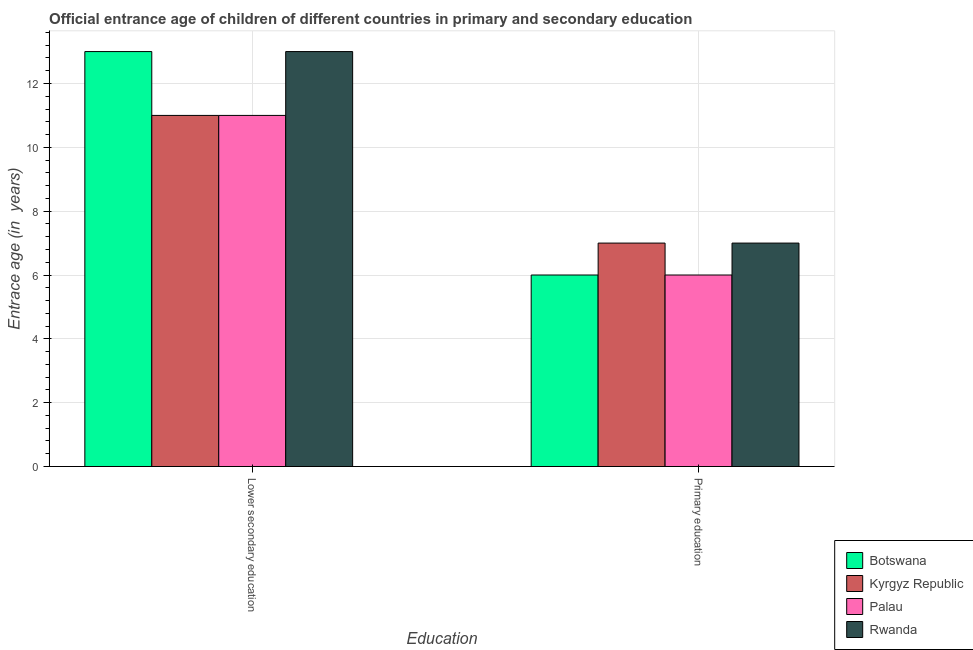Are the number of bars per tick equal to the number of legend labels?
Give a very brief answer. Yes. Are the number of bars on each tick of the X-axis equal?
Your answer should be compact. Yes. How many bars are there on the 1st tick from the left?
Provide a succinct answer. 4. How many bars are there on the 1st tick from the right?
Offer a terse response. 4. What is the label of the 2nd group of bars from the left?
Offer a very short reply. Primary education. What is the entrance age of chiildren in primary education in Botswana?
Offer a terse response. 6. Across all countries, what is the maximum entrance age of chiildren in primary education?
Make the answer very short. 7. Across all countries, what is the minimum entrance age of children in lower secondary education?
Provide a short and direct response. 11. In which country was the entrance age of chiildren in primary education maximum?
Provide a short and direct response. Kyrgyz Republic. In which country was the entrance age of children in lower secondary education minimum?
Your response must be concise. Kyrgyz Republic. What is the total entrance age of chiildren in primary education in the graph?
Your answer should be compact. 26. What is the difference between the entrance age of chiildren in primary education in Botswana and that in Kyrgyz Republic?
Give a very brief answer. -1. What is the difference between the entrance age of children in lower secondary education in Rwanda and the entrance age of chiildren in primary education in Palau?
Ensure brevity in your answer.  7. What is the difference between the entrance age of children in lower secondary education and entrance age of chiildren in primary education in Kyrgyz Republic?
Provide a succinct answer. 4. What is the ratio of the entrance age of chiildren in primary education in Botswana to that in Kyrgyz Republic?
Ensure brevity in your answer.  0.86. What does the 4th bar from the left in Primary education represents?
Offer a terse response. Rwanda. What does the 2nd bar from the right in Lower secondary education represents?
Offer a terse response. Palau. Are all the bars in the graph horizontal?
Keep it short and to the point. No. What is the difference between two consecutive major ticks on the Y-axis?
Your answer should be compact. 2. Where does the legend appear in the graph?
Your response must be concise. Bottom right. What is the title of the graph?
Offer a very short reply. Official entrance age of children of different countries in primary and secondary education. Does "Bangladesh" appear as one of the legend labels in the graph?
Keep it short and to the point. No. What is the label or title of the X-axis?
Give a very brief answer. Education. What is the label or title of the Y-axis?
Provide a succinct answer. Entrace age (in  years). What is the Entrace age (in  years) in Palau in Lower secondary education?
Your answer should be compact. 11. What is the Entrace age (in  years) in Botswana in Primary education?
Your answer should be compact. 6. What is the Entrace age (in  years) of Rwanda in Primary education?
Your answer should be compact. 7. Across all Education, what is the maximum Entrace age (in  years) in Kyrgyz Republic?
Provide a succinct answer. 11. Across all Education, what is the maximum Entrace age (in  years) of Palau?
Your answer should be compact. 11. Across all Education, what is the maximum Entrace age (in  years) of Rwanda?
Ensure brevity in your answer.  13. Across all Education, what is the minimum Entrace age (in  years) of Kyrgyz Republic?
Offer a terse response. 7. Across all Education, what is the minimum Entrace age (in  years) of Palau?
Your answer should be compact. 6. Across all Education, what is the minimum Entrace age (in  years) in Rwanda?
Keep it short and to the point. 7. What is the total Entrace age (in  years) in Kyrgyz Republic in the graph?
Ensure brevity in your answer.  18. What is the total Entrace age (in  years) in Palau in the graph?
Offer a very short reply. 17. What is the total Entrace age (in  years) of Rwanda in the graph?
Offer a very short reply. 20. What is the difference between the Entrace age (in  years) of Kyrgyz Republic in Lower secondary education and that in Primary education?
Offer a terse response. 4. What is the difference between the Entrace age (in  years) of Palau in Lower secondary education and that in Primary education?
Offer a terse response. 5. What is the difference between the Entrace age (in  years) of Botswana in Lower secondary education and the Entrace age (in  years) of Kyrgyz Republic in Primary education?
Your response must be concise. 6. What is the difference between the Entrace age (in  years) of Kyrgyz Republic in Lower secondary education and the Entrace age (in  years) of Palau in Primary education?
Provide a succinct answer. 5. What is the average Entrace age (in  years) of Rwanda per Education?
Give a very brief answer. 10. What is the difference between the Entrace age (in  years) of Botswana and Entrace age (in  years) of Kyrgyz Republic in Lower secondary education?
Keep it short and to the point. 2. What is the difference between the Entrace age (in  years) in Kyrgyz Republic and Entrace age (in  years) in Palau in Lower secondary education?
Ensure brevity in your answer.  0. What is the difference between the Entrace age (in  years) in Botswana and Entrace age (in  years) in Rwanda in Primary education?
Provide a succinct answer. -1. What is the difference between the Entrace age (in  years) in Kyrgyz Republic and Entrace age (in  years) in Palau in Primary education?
Ensure brevity in your answer.  1. What is the ratio of the Entrace age (in  years) of Botswana in Lower secondary education to that in Primary education?
Your answer should be very brief. 2.17. What is the ratio of the Entrace age (in  years) in Kyrgyz Republic in Lower secondary education to that in Primary education?
Make the answer very short. 1.57. What is the ratio of the Entrace age (in  years) in Palau in Lower secondary education to that in Primary education?
Make the answer very short. 1.83. What is the ratio of the Entrace age (in  years) in Rwanda in Lower secondary education to that in Primary education?
Make the answer very short. 1.86. What is the difference between the highest and the second highest Entrace age (in  years) in Kyrgyz Republic?
Ensure brevity in your answer.  4. What is the difference between the highest and the second highest Entrace age (in  years) in Rwanda?
Provide a short and direct response. 6. What is the difference between the highest and the lowest Entrace age (in  years) in Botswana?
Offer a terse response. 7. What is the difference between the highest and the lowest Entrace age (in  years) of Kyrgyz Republic?
Your answer should be compact. 4. 